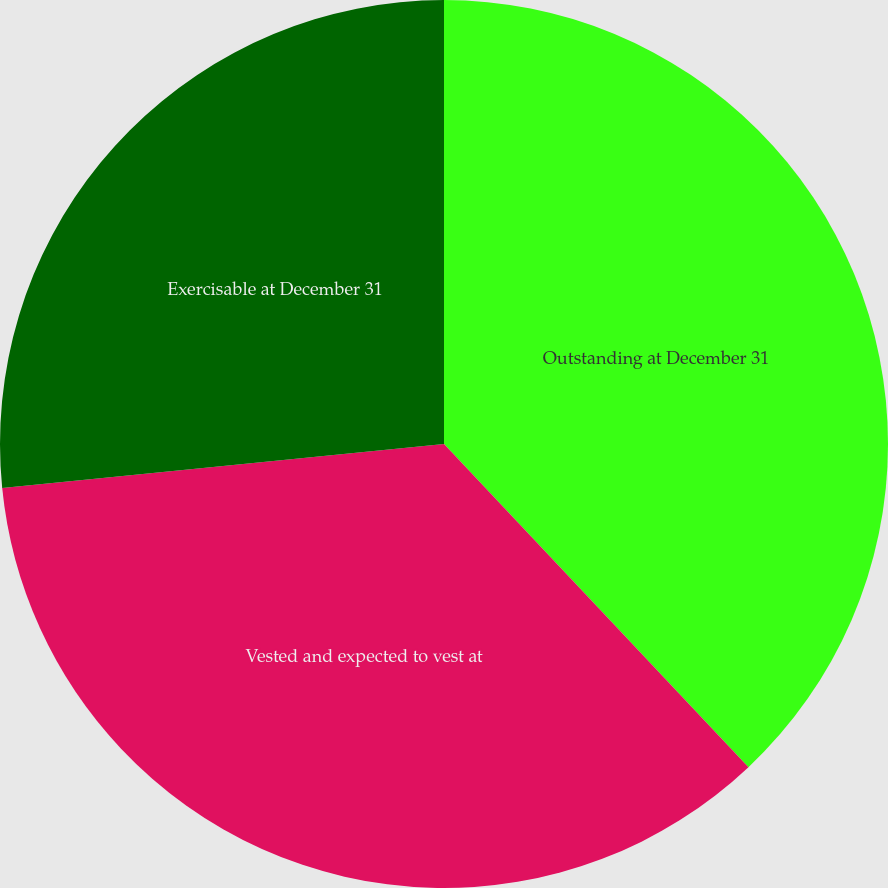Convert chart. <chart><loc_0><loc_0><loc_500><loc_500><pie_chart><fcel>Outstanding at December 31<fcel>Vested and expected to vest at<fcel>Exercisable at December 31<nl><fcel>37.97%<fcel>35.44%<fcel>26.58%<nl></chart> 